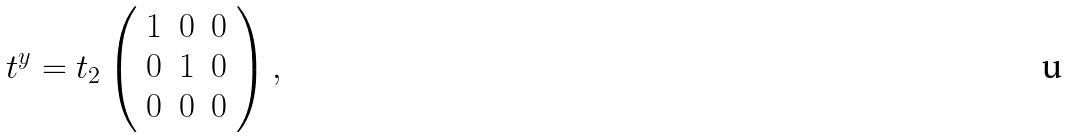<formula> <loc_0><loc_0><loc_500><loc_500>t ^ { y } = t _ { 2 } \left ( \begin{array} { c c c } 1 & 0 & 0 \\ 0 & 1 & 0 \\ 0 & 0 & 0 \\ \end{array} \right ) ,</formula> 